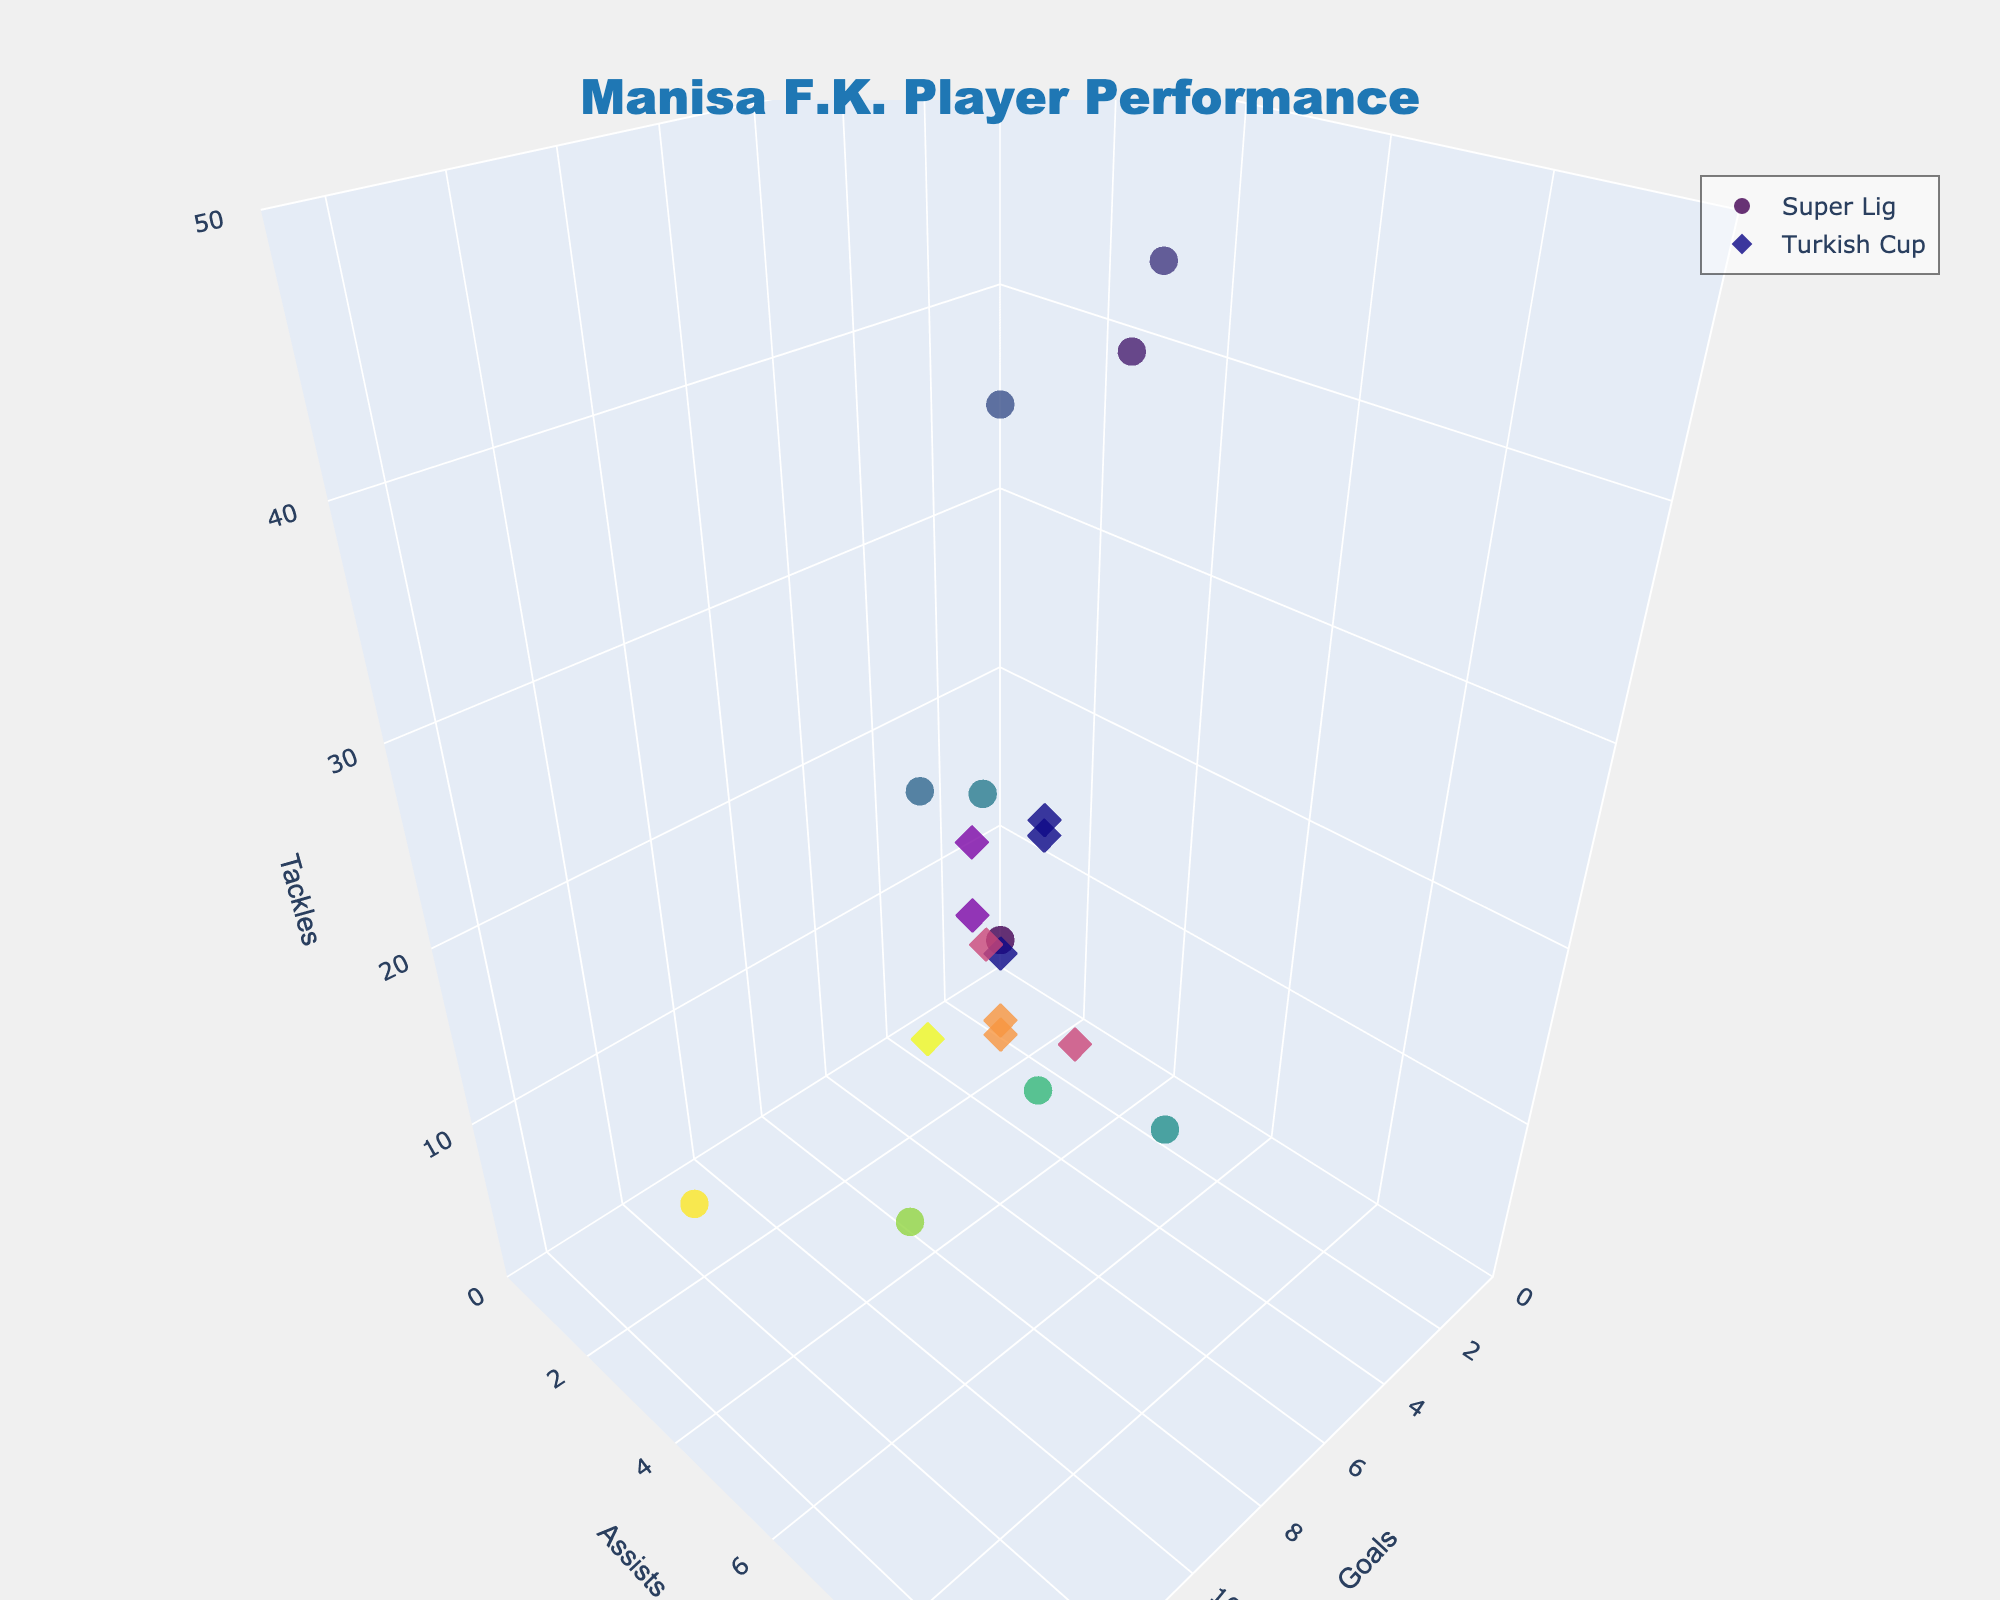What is the title of the plot? The title is located at the top center of the plot, usually in bold and larger font size to make it prominent. By looking at the top of the plot, you can find the title mentioned there.
Answer: Manisa F.K. Player Performance How many players are represented in the Super Lig dataset? Each data point in the 3D scatter plot corresponds to a player. By counting the number of data points labeled as 'Super Lig', you can determine the number of players.
Answer: 10 Which player has the highest number of tackles in the Turkish Cup? Locate the dataset labeled 'Turkish Cup' in the plot. Then, find the data point with the highest value on the z-axis (Tackles). The player associated with this data point has the most tackles.
Answer: Emir Karic What is the total number of goals scored by Umut Nayir across both competitions? First, identify the data points for Umut Nayir in both 'Super Lig' and 'Turkish Cup'. Next, sum the goals (x-axis values) from these data points.
Answer: 16 Who has more assists in the Super Lig, Doğukan Sinik or Burak Yılmaz? Locate the data points for Doğukan Sinik and Burak Yılmaz in the 'Super Lig' dataset. Compare their y-axis values (Assists).
Answer: Doğukan Sinik How many total tackles were made by Halil Akbunar across both competitions? Identify Halil Akbunar's data points in both 'Super Lig' and 'Turkish Cup'. Sum the z-axis values (Tackles) from these data points.
Answer: 19 What is the average number of goals scored by players in the 'Super Lig'? Identify all the data points in the 'Super Lig' dataset. Sum the x-axis values (Goals) for these points and then divide by the number of players.
Answer: 5.1 Which competition has the player with the maximum number of assists? Compare the highest y-axis values (Assists) between the 'Super Lig' and 'Turkish Cup' datasets. The competition with the higher value contains the player with the maximum assists.
Answer: Super Lig Who scored more goals in the Turkish Cup, Umut Nayir or Baiano? Locate Umut Nayir's and Baiano's data points in the 'Turkish Cup' dataset. Compare their x-axis values (Goals).
Answer: Umut Nayir Which player has the largest variation in their number of tackles between the two competitions? Identify each player's data points in both competitions and calculate the difference in z-axis values (Tackles) for each player. The player with the largest absolute difference has the most variation.
Answer: Arda Kızıldağ 